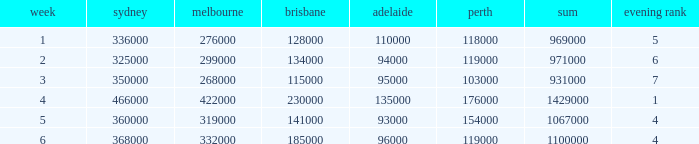What was the rating in Brisbane the week it was 276000 in Melbourne?  128000.0. 